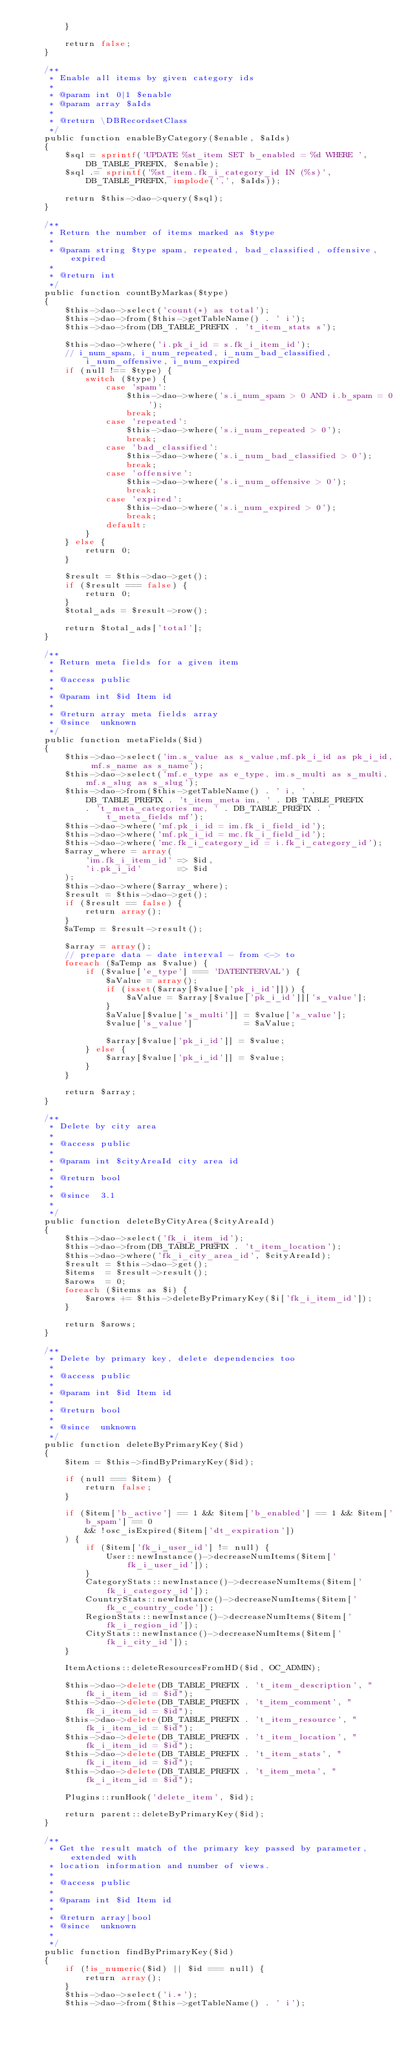<code> <loc_0><loc_0><loc_500><loc_500><_PHP_>        }

        return false;
    }

    /**
     * Enable all items by given category ids
     *
     * @param int 0|1 $enable
     * @param array $aIds
     *
     * @return \DBRecordsetClass
     */
    public function enableByCategory($enable, $aIds)
    {
        $sql = sprintf('UPDATE %st_item SET b_enabled = %d WHERE ', DB_TABLE_PREFIX, $enable);
        $sql .= sprintf('%st_item.fk_i_category_id IN (%s)', DB_TABLE_PREFIX, implode(',', $aIds));

        return $this->dao->query($sql);
    }

    /**
     * Return the number of items marked as $type
     *
     * @param string $type spam, repeated, bad_classified, offensive, expired
     *
     * @return int
     */
    public function countByMarkas($type)
    {
        $this->dao->select('count(*) as total');
        $this->dao->from($this->getTableName() . ' i');
        $this->dao->from(DB_TABLE_PREFIX . 't_item_stats s');

        $this->dao->where('i.pk_i_id = s.fk_i_item_id');
        // i_num_spam, i_num_repeated, i_num_bad_classified, i_num_offensive, i_num_expired
        if (null !== $type) {
            switch ($type) {
                case 'spam':
                    $this->dao->where('s.i_num_spam > 0 AND i.b_spam = 0');
                    break;
                case 'repeated':
                    $this->dao->where('s.i_num_repeated > 0');
                    break;
                case 'bad_classified':
                    $this->dao->where('s.i_num_bad_classified > 0');
                    break;
                case 'offensive':
                    $this->dao->where('s.i_num_offensive > 0');
                    break;
                case 'expired':
                    $this->dao->where('s.i_num_expired > 0');
                    break;
                default:
            }
        } else {
            return 0;
        }

        $result = $this->dao->get();
        if ($result === false) {
            return 0;
        }
        $total_ads = $result->row();

        return $total_ads['total'];
    }

    /**
     * Return meta fields for a given item
     *
     * @access public
     *
     * @param int $id Item id
     *
     * @return array meta fields array
     * @since  unknown
     */
    public function metaFields($id)
    {
        $this->dao->select('im.s_value as s_value,mf.pk_i_id as pk_i_id, mf.s_name as s_name');
        $this->dao->select('mf.e_type as e_type, im.s_multi as s_multi, mf.s_slug as s_slug');
        $this->dao->from($this->getTableName() . ' i, ' . DB_TABLE_PREFIX . 't_item_meta im, ' . DB_TABLE_PREFIX
            . 't_meta_categories mc, ' . DB_TABLE_PREFIX . 't_meta_fields mf');
        $this->dao->where('mf.pk_i_id = im.fk_i_field_id');
        $this->dao->where('mf.pk_i_id = mc.fk_i_field_id');
        $this->dao->where('mc.fk_i_category_id = i.fk_i_category_id');
        $array_where = array(
            'im.fk_i_item_id' => $id,
            'i.pk_i_id'       => $id
        );
        $this->dao->where($array_where);
        $result = $this->dao->get();
        if ($result == false) {
            return array();
        }
        $aTemp = $result->result();

        $array = array();
        // prepare data - date interval - from <-> to
        foreach ($aTemp as $value) {
            if ($value['e_type'] === 'DATEINTERVAL') {
                $aValue = array();
                if (isset($array[$value['pk_i_id']])) {
                    $aValue = $array[$value['pk_i_id']]['s_value'];
                }
                $aValue[$value['s_multi']] = $value['s_value'];
                $value['s_value']          = $aValue;

                $array[$value['pk_i_id']] = $value;
            } else {
                $array[$value['pk_i_id']] = $value;
            }
        }

        return $array;
    }

    /**
     * Delete by city area
     *
     * @access public
     *
     * @param int $cityAreaId city area id
     *
     * @return bool
     *
     * @since  3.1
     *
     */
    public function deleteByCityArea($cityAreaId)
    {
        $this->dao->select('fk_i_item_id');
        $this->dao->from(DB_TABLE_PREFIX . 't_item_location');
        $this->dao->where('fk_i_city_area_id', $cityAreaId);
        $result = $this->dao->get();
        $items  = $result->result();
        $arows  = 0;
        foreach ($items as $i) {
            $arows += $this->deleteByPrimaryKey($i['fk_i_item_id']);
        }

        return $arows;
    }

    /**
     * Delete by primary key, delete dependencies too
     *
     * @access public
     *
     * @param int $id Item id
     *
     * @return bool
     *
     * @since  unknown
     */
    public function deleteByPrimaryKey($id)
    {
        $item = $this->findByPrimaryKey($id);

        if (null === $item) {
            return false;
        }

        if ($item['b_active'] == 1 && $item['b_enabled'] == 1 && $item['b_spam'] == 0
            && !osc_isExpired($item['dt_expiration'])
        ) {
            if ($item['fk_i_user_id'] != null) {
                User::newInstance()->decreaseNumItems($item['fk_i_user_id']);
            }
            CategoryStats::newInstance()->decreaseNumItems($item['fk_i_category_id']);
            CountryStats::newInstance()->decreaseNumItems($item['fk_c_country_code']);
            RegionStats::newInstance()->decreaseNumItems($item['fk_i_region_id']);
            CityStats::newInstance()->decreaseNumItems($item['fk_i_city_id']);
        }

        ItemActions::deleteResourcesFromHD($id, OC_ADMIN);

        $this->dao->delete(DB_TABLE_PREFIX . 't_item_description', "fk_i_item_id = $id");
        $this->dao->delete(DB_TABLE_PREFIX . 't_item_comment', "fk_i_item_id = $id");
        $this->dao->delete(DB_TABLE_PREFIX . 't_item_resource', "fk_i_item_id = $id");
        $this->dao->delete(DB_TABLE_PREFIX . 't_item_location', "fk_i_item_id = $id");
        $this->dao->delete(DB_TABLE_PREFIX . 't_item_stats', "fk_i_item_id = $id");
        $this->dao->delete(DB_TABLE_PREFIX . 't_item_meta', "fk_i_item_id = $id");

        Plugins::runHook('delete_item', $id);

        return parent::deleteByPrimaryKey($id);
    }

    /**
     * Get the result match of the primary key passed by parameter, extended with
     * location information and number of views.
     *
     * @access public
     *
     * @param int $id Item id
     *
     * @return array|bool
     * @since  unknown
     *
     */
    public function findByPrimaryKey($id)
    {
        if (!is_numeric($id) || $id === null) {
            return array();
        }
        $this->dao->select('i.*');
        $this->dao->from($this->getTableName() . ' i');</code> 